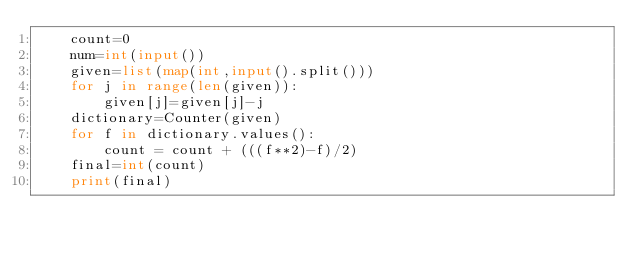<code> <loc_0><loc_0><loc_500><loc_500><_Python_>    count=0
    num=int(input())
    given=list(map(int,input().split()))
    for j in range(len(given)):
        given[j]=given[j]-j
    dictionary=Counter(given)
    for f in dictionary.values():
        count = count + (((f**2)-f)/2)
    final=int(count)
    print(final)</code> 